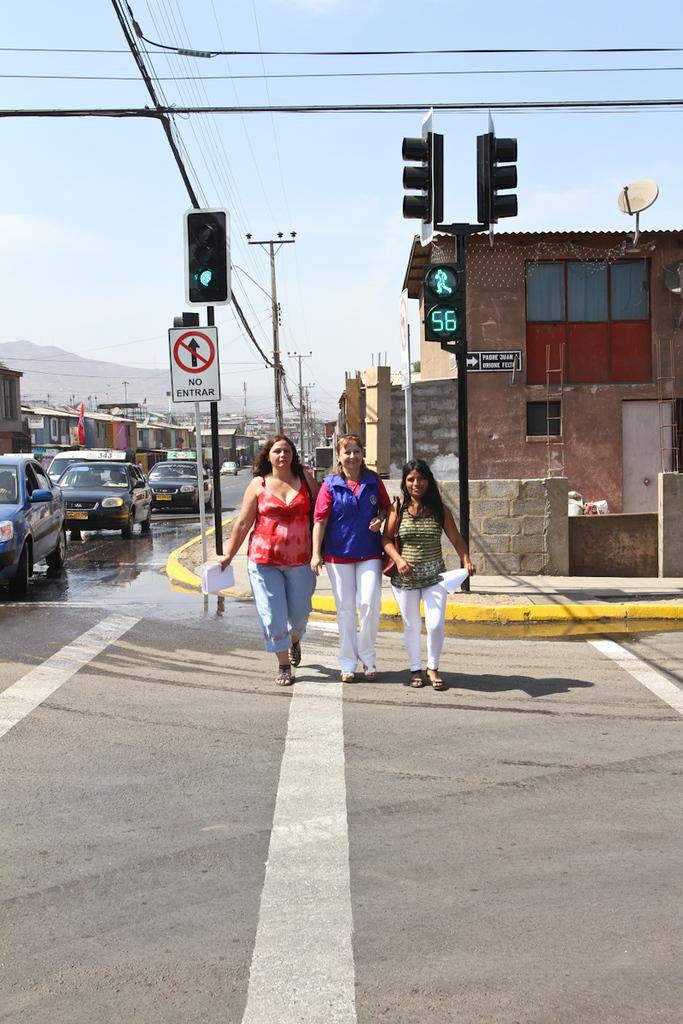What type of structure is visible in the image? There is a house in the image. What can be seen controlling the flow of traffic in the image? There is a traffic signal in the image. What are the people in the image doing? There are people walking in the image. What type of vehicles are present in the image? There are cars in the image. What other structures can be seen in the image besides the house? There are buildings in the image. What is the source of electricity for the area in the image? There is a current pole in the image. What part of the natural environment is visible in the image? The sky is visible in the image. How many sticks are being used to make a profit in the image? There are no sticks or references to profit in the image. Can you see any wings on the people walking in the image? There are no wings visible on the people walking in the image. 